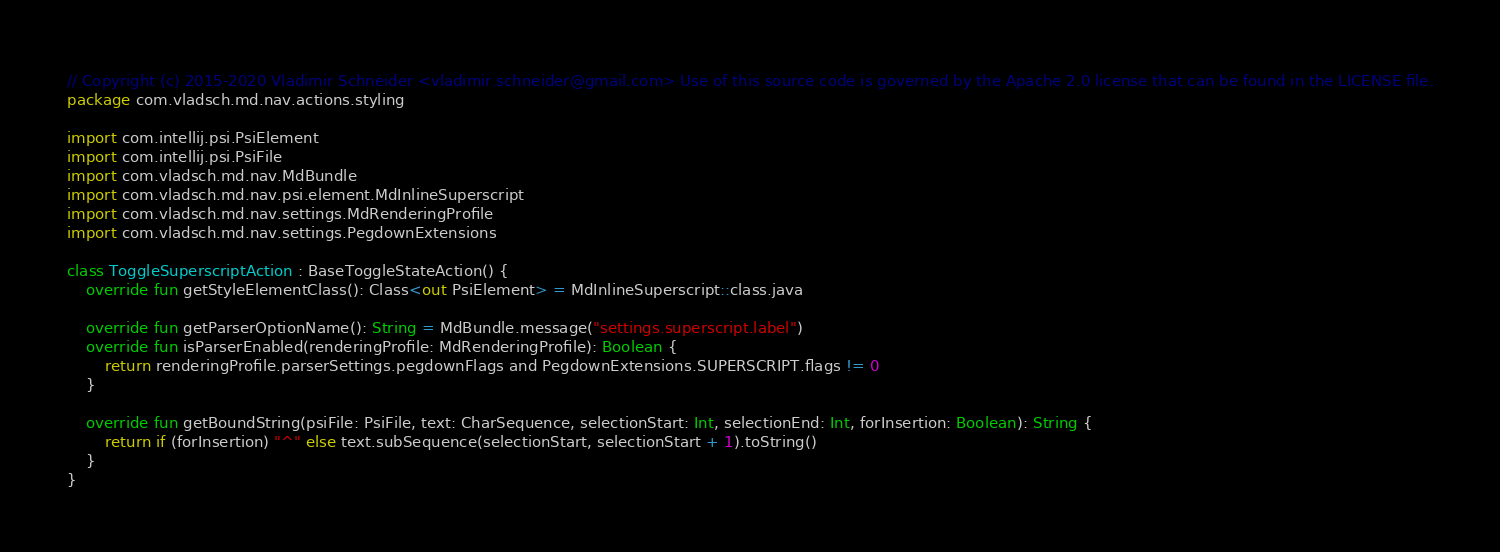Convert code to text. <code><loc_0><loc_0><loc_500><loc_500><_Kotlin_>// Copyright (c) 2015-2020 Vladimir Schneider <vladimir.schneider@gmail.com> Use of this source code is governed by the Apache 2.0 license that can be found in the LICENSE file.
package com.vladsch.md.nav.actions.styling

import com.intellij.psi.PsiElement
import com.intellij.psi.PsiFile
import com.vladsch.md.nav.MdBundle
import com.vladsch.md.nav.psi.element.MdInlineSuperscript
import com.vladsch.md.nav.settings.MdRenderingProfile
import com.vladsch.md.nav.settings.PegdownExtensions

class ToggleSuperscriptAction : BaseToggleStateAction() {
    override fun getStyleElementClass(): Class<out PsiElement> = MdInlineSuperscript::class.java

    override fun getParserOptionName(): String = MdBundle.message("settings.superscript.label")
    override fun isParserEnabled(renderingProfile: MdRenderingProfile): Boolean {
        return renderingProfile.parserSettings.pegdownFlags and PegdownExtensions.SUPERSCRIPT.flags != 0
    }

    override fun getBoundString(psiFile: PsiFile, text: CharSequence, selectionStart: Int, selectionEnd: Int, forInsertion: Boolean): String {
        return if (forInsertion) "^" else text.subSequence(selectionStart, selectionStart + 1).toString()
    }
}
</code> 